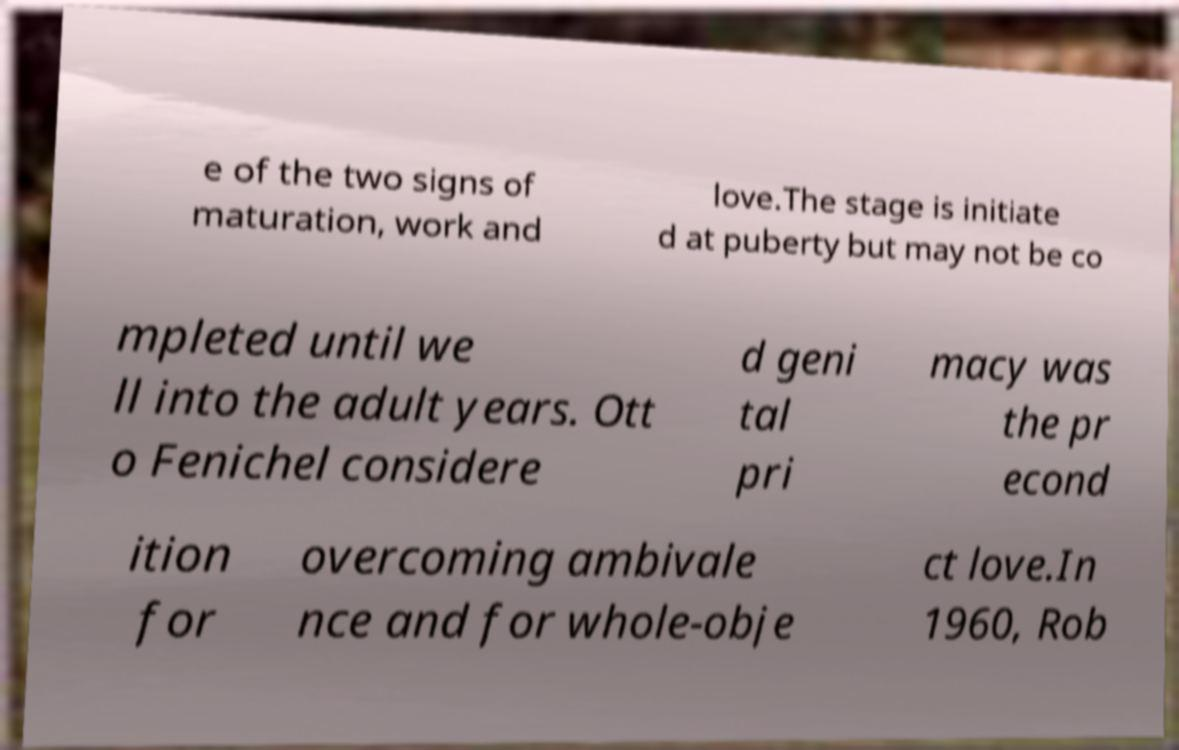There's text embedded in this image that I need extracted. Can you transcribe it verbatim? e of the two signs of maturation, work and love.The stage is initiate d at puberty but may not be co mpleted until we ll into the adult years. Ott o Fenichel considere d geni tal pri macy was the pr econd ition for overcoming ambivale nce and for whole-obje ct love.In 1960, Rob 